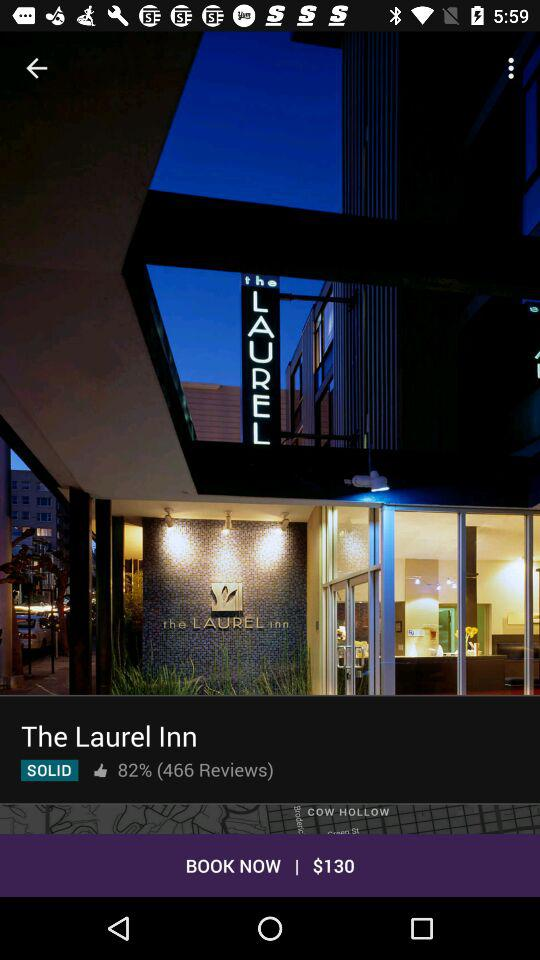How many reviews does The Laurel Inn have?
Answer the question using a single word or phrase. 466 